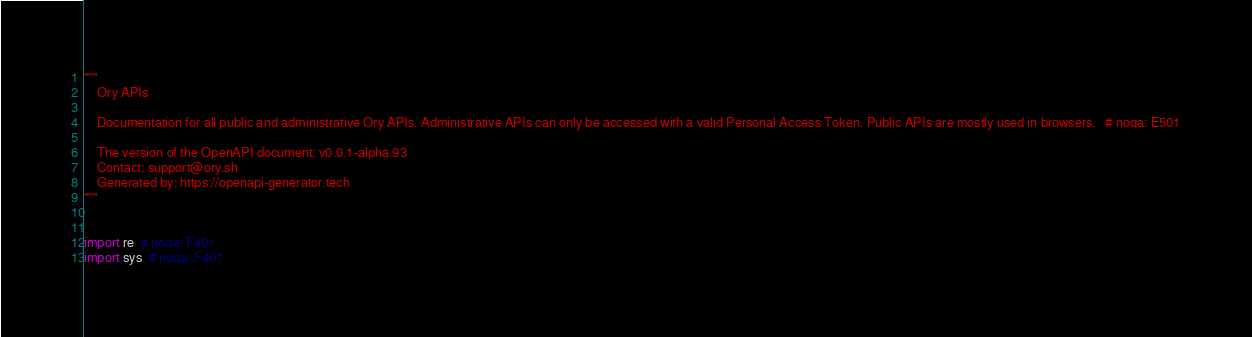<code> <loc_0><loc_0><loc_500><loc_500><_Python_>"""
    Ory APIs

    Documentation for all public and administrative Ory APIs. Administrative APIs can only be accessed with a valid Personal Access Token. Public APIs are mostly used in browsers.   # noqa: E501

    The version of the OpenAPI document: v0.0.1-alpha.93
    Contact: support@ory.sh
    Generated by: https://openapi-generator.tech
"""


import re  # noqa: F401
import sys  # noqa: F401
</code> 